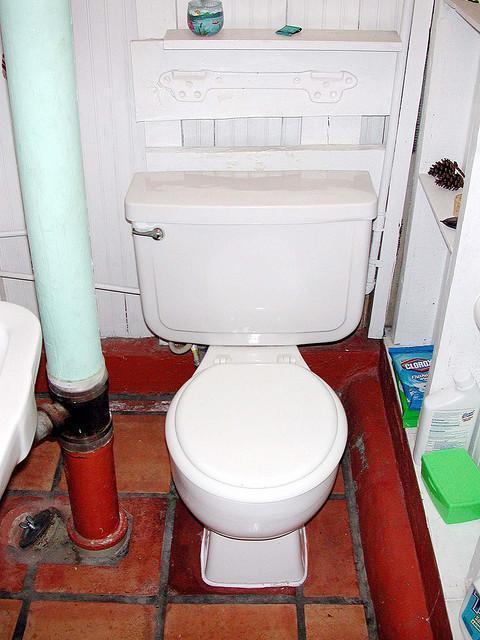How many colors can you identify on the pipe to the left of the toilet?
Give a very brief answer. 3. 